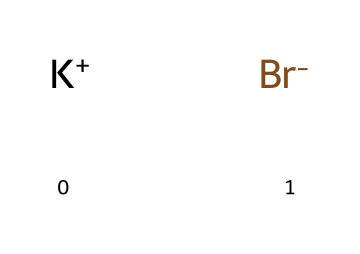What is the molecular formula of potassium bromide? The SMILES representation shows one potassium ion (K+) and one bromide ion (Br-), which combine to form potassium bromide. Therefore, the molecular formula consists of these two ions: K and Br.
Answer: KBr How many atoms are present in potassium bromide? The structure indicates two ions: one potassium ion (K+) and one bromide ion (Br-). Since each ion represents one atom, the total number of atoms is two.
Answer: 2 What charge does potassium carry in this compound? In the SMILES representation, potassium is represented as K+. The '+' sign indicates that it carries a positive charge.
Answer: positive What is the role of bromide in potassium bromide? The bromide ion (Br-) serves as the anion in this compound, pairing with the cation potassium (K+) to form a neutral ionic compound. Its role is essential for the compound's electrical neutrality.
Answer: anion What type of electrolyte is potassium bromide? Potassium bromide is classified as a strong electrolyte because it fully dissociates into its ions in solution, thereby conducting electricity well.
Answer: strong How does the ionic nature of potassium bromide affect its solubility in water? Being an ionic compound, potassium bromide dissociates into K+ and Br- ions when it dissolves in water. This dissolution leads to high solubility due to the strong interactions between the ions and water molecules.
Answer: high solubility 